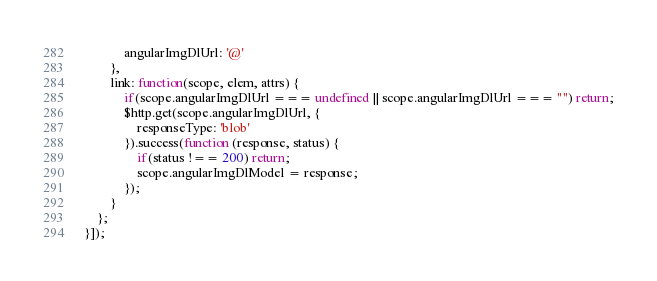<code> <loc_0><loc_0><loc_500><loc_500><_JavaScript_>			angularImgDlUrl: '@'
		},
		link: function(scope, elem, attrs) {
			if(scope.angularImgDlUrl === undefined || scope.angularImgDlUrl === "") return;
			$http.get(scope.angularImgDlUrl, {
				responseType: 'blob'
			}).success(function (response, status) {
				if(status !== 200) return;
				scope.angularImgDlModel = response;
			});
		}
	};
}]);
</code> 